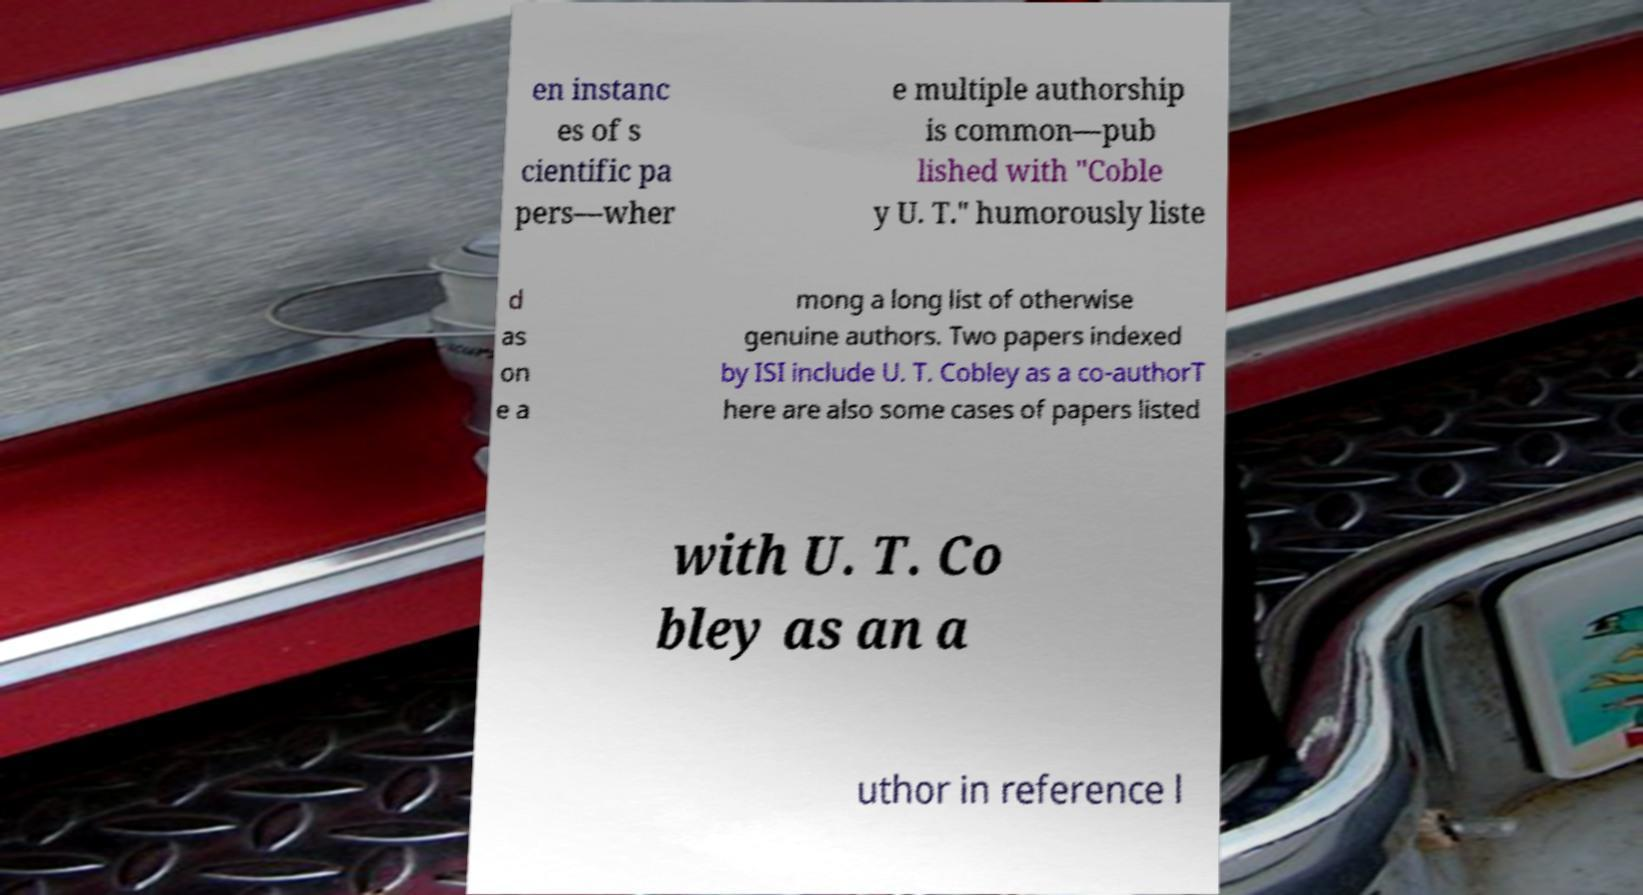Can you accurately transcribe the text from the provided image for me? en instanc es of s cientific pa pers—wher e multiple authorship is common—pub lished with "Coble y U. T." humorously liste d as on e a mong a long list of otherwise genuine authors. Two papers indexed by ISI include U. T. Cobley as a co-authorT here are also some cases of papers listed with U. T. Co bley as an a uthor in reference l 